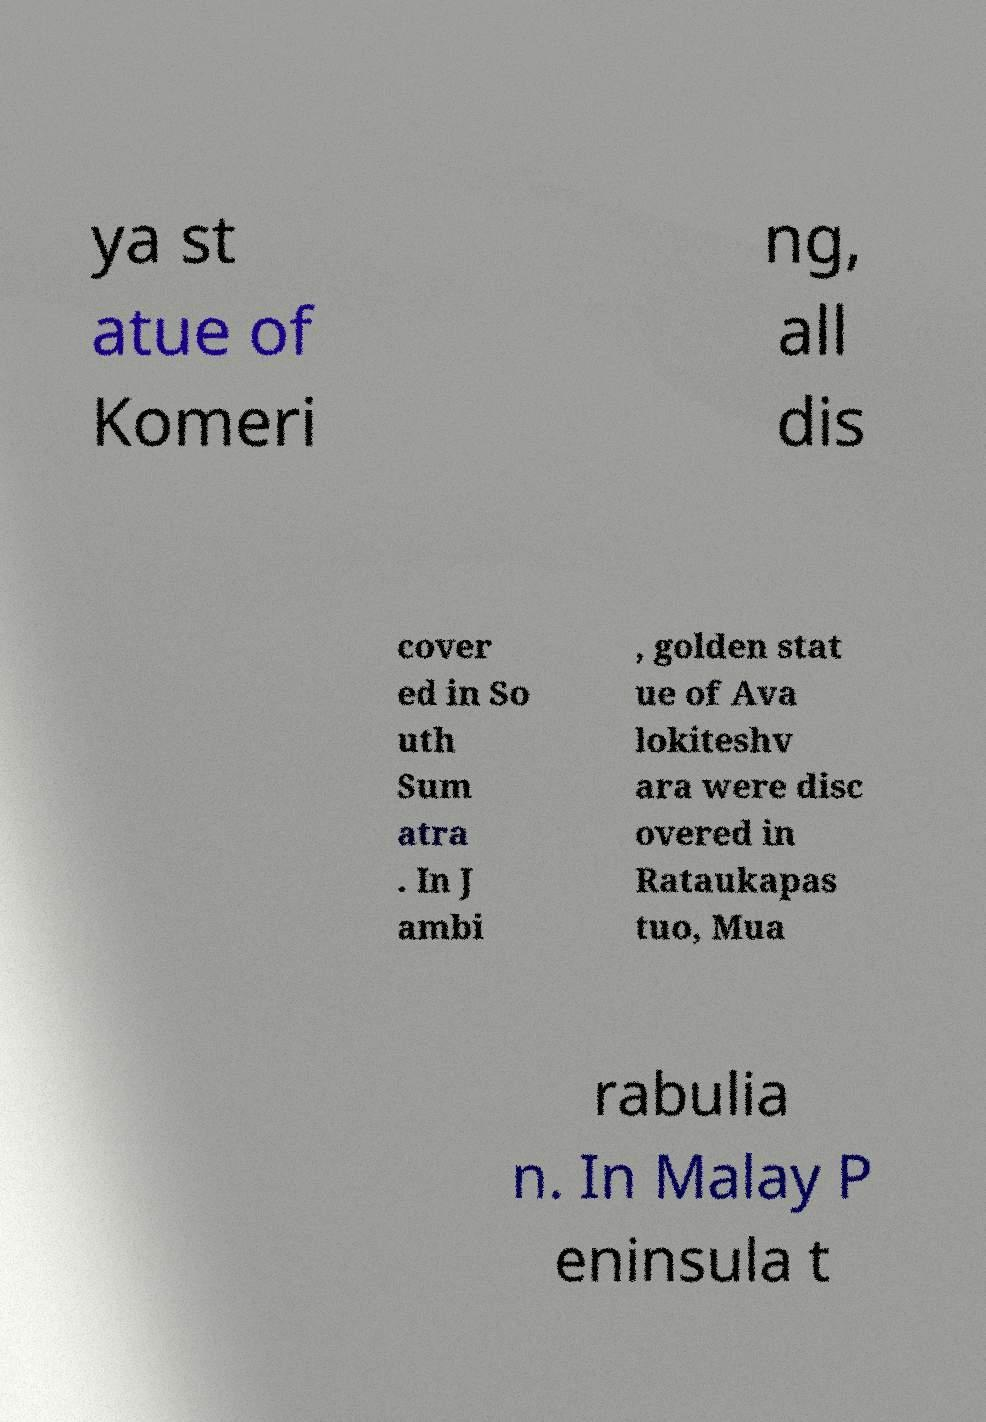Can you read and provide the text displayed in the image?This photo seems to have some interesting text. Can you extract and type it out for me? ya st atue of Komeri ng, all dis cover ed in So uth Sum atra . In J ambi , golden stat ue of Ava lokiteshv ara were disc overed in Rataukapas tuo, Mua rabulia n. In Malay P eninsula t 